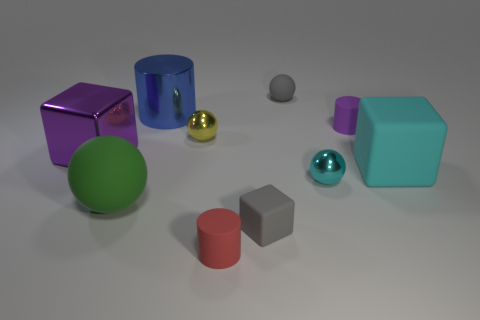How many things are small cyan metallic blocks or small cyan metal objects?
Your answer should be compact. 1. There is a gray thing that is behind the large purple metal cube; what is its size?
Ensure brevity in your answer.  Small. How many big matte cubes are left of the big cube left of the cylinder in front of the big cyan cube?
Ensure brevity in your answer.  0. Is the big cylinder the same color as the tiny cube?
Offer a terse response. No. How many things are behind the small rubber cube and on the right side of the metal block?
Provide a succinct answer. 7. The gray rubber object that is behind the yellow thing has what shape?
Offer a terse response. Sphere. Is the number of purple rubber objects that are in front of the green thing less than the number of purple cylinders on the left side of the red rubber cylinder?
Your answer should be compact. No. Do the block on the left side of the yellow metallic ball and the large thing that is right of the small red cylinder have the same material?
Ensure brevity in your answer.  No. What is the shape of the yellow metallic thing?
Offer a terse response. Sphere. Is the number of tiny yellow balls that are behind the tiny yellow thing greater than the number of large rubber objects that are right of the gray rubber block?
Provide a short and direct response. No. 